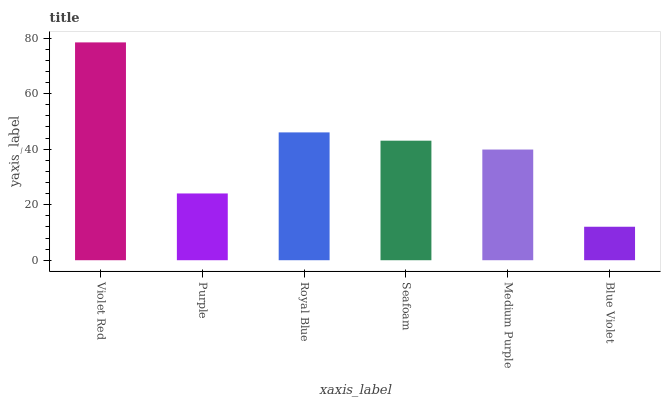Is Purple the minimum?
Answer yes or no. No. Is Purple the maximum?
Answer yes or no. No. Is Violet Red greater than Purple?
Answer yes or no. Yes. Is Purple less than Violet Red?
Answer yes or no. Yes. Is Purple greater than Violet Red?
Answer yes or no. No. Is Violet Red less than Purple?
Answer yes or no. No. Is Seafoam the high median?
Answer yes or no. Yes. Is Medium Purple the low median?
Answer yes or no. Yes. Is Violet Red the high median?
Answer yes or no. No. Is Blue Violet the low median?
Answer yes or no. No. 